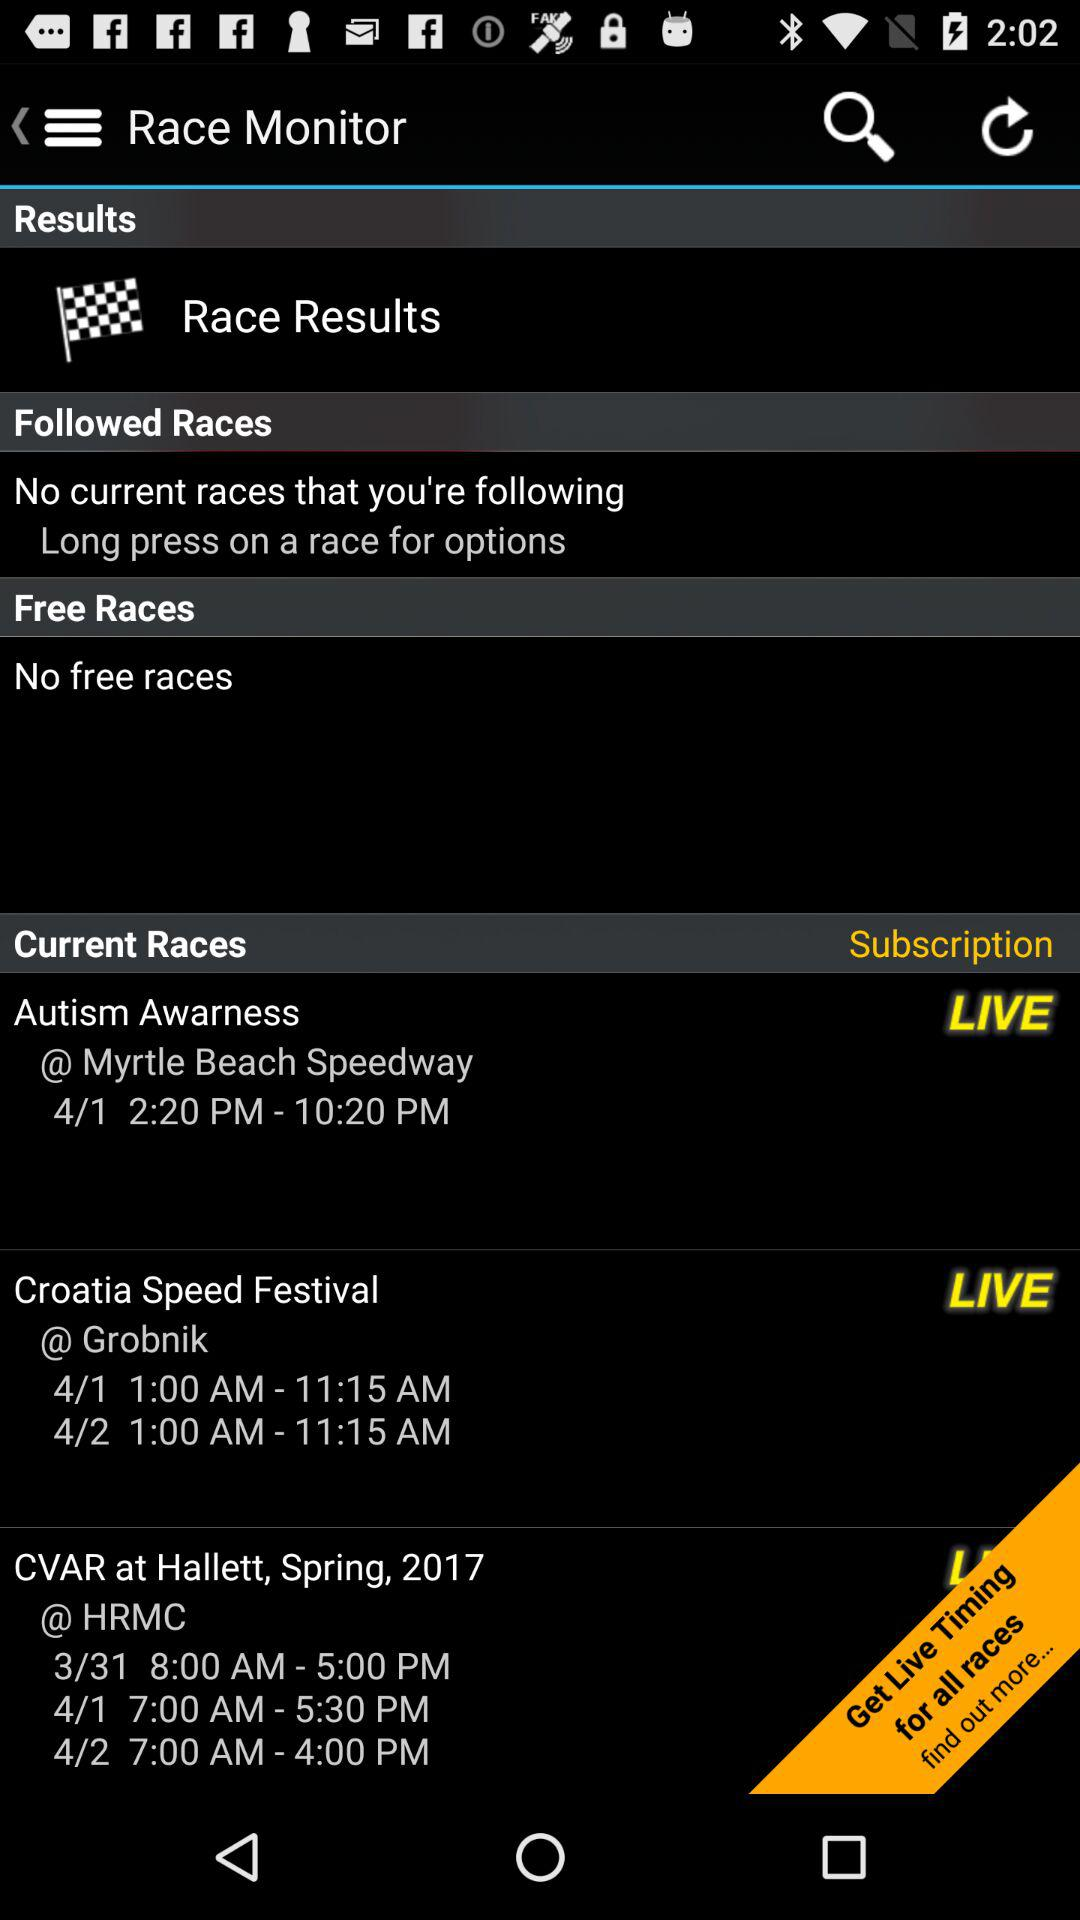How many free races are there? There are no free races. 